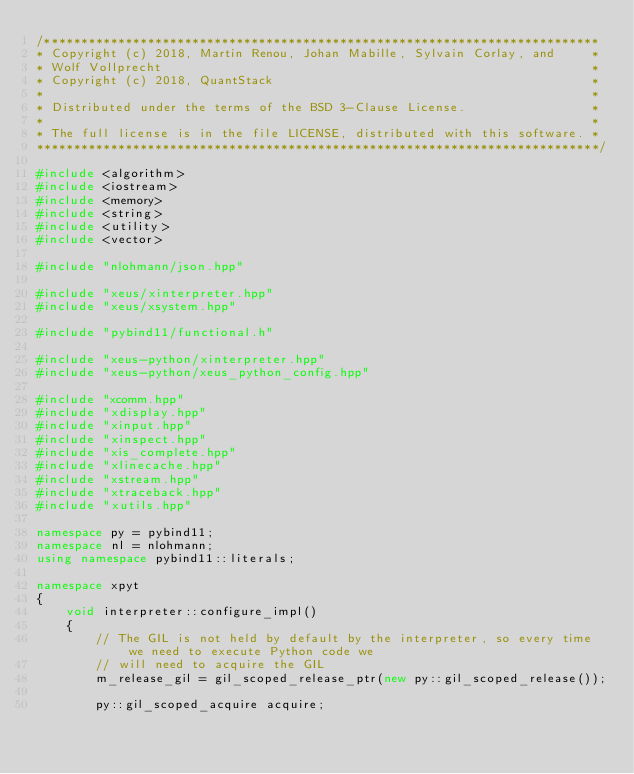<code> <loc_0><loc_0><loc_500><loc_500><_C++_>/***************************************************************************
* Copyright (c) 2018, Martin Renou, Johan Mabille, Sylvain Corlay, and     *
* Wolf Vollprecht                                                          *
* Copyright (c) 2018, QuantStack                                           *
*                                                                          *
* Distributed under the terms of the BSD 3-Clause License.                 *
*                                                                          *
* The full license is in the file LICENSE, distributed with this software. *
****************************************************************************/

#include <algorithm>
#include <iostream>
#include <memory>
#include <string>
#include <utility>
#include <vector>

#include "nlohmann/json.hpp"

#include "xeus/xinterpreter.hpp"
#include "xeus/xsystem.hpp"

#include "pybind11/functional.h"

#include "xeus-python/xinterpreter.hpp"
#include "xeus-python/xeus_python_config.hpp"

#include "xcomm.hpp"
#include "xdisplay.hpp"
#include "xinput.hpp"
#include "xinspect.hpp"
#include "xis_complete.hpp"
#include "xlinecache.hpp"
#include "xstream.hpp"
#include "xtraceback.hpp"
#include "xutils.hpp"

namespace py = pybind11;
namespace nl = nlohmann;
using namespace pybind11::literals;

namespace xpyt
{
    void interpreter::configure_impl()
    {
        // The GIL is not held by default by the interpreter, so every time we need to execute Python code we
        // will need to acquire the GIL
        m_release_gil = gil_scoped_release_ptr(new py::gil_scoped_release());

        py::gil_scoped_acquire acquire;</code> 